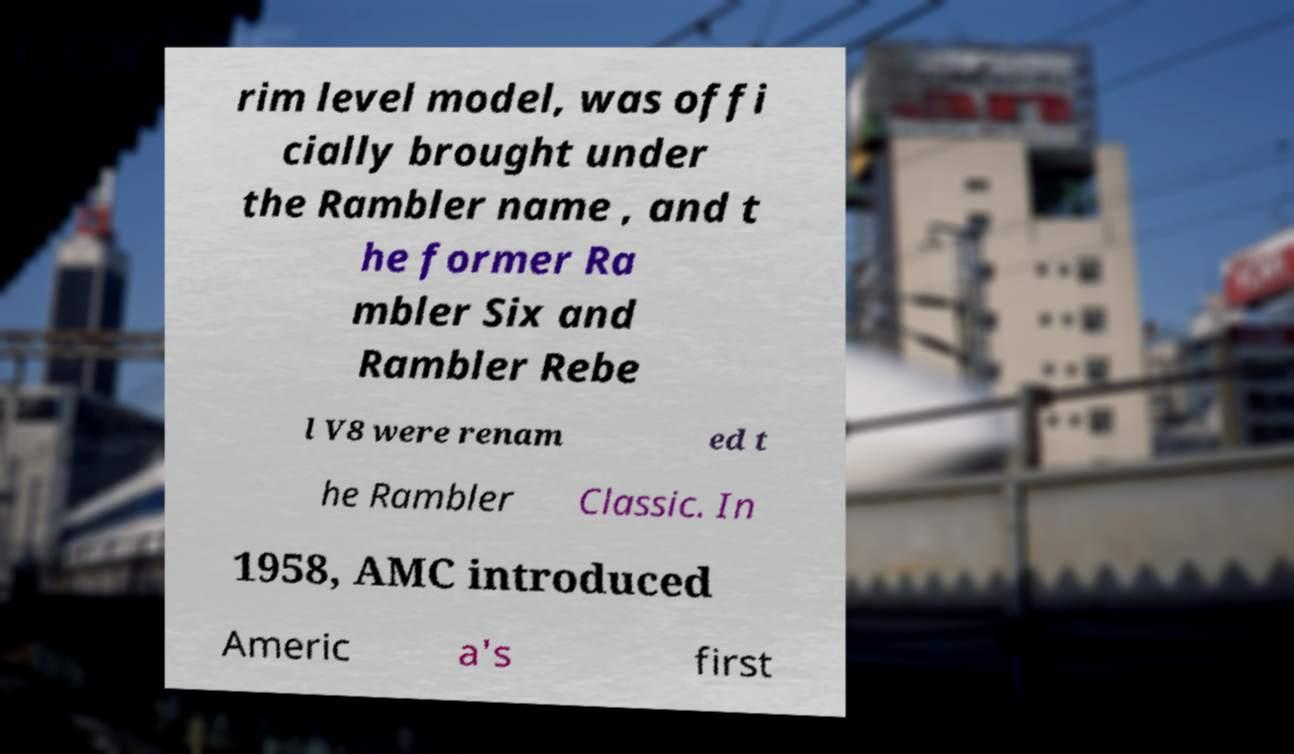Could you extract and type out the text from this image? rim level model, was offi cially brought under the Rambler name , and t he former Ra mbler Six and Rambler Rebe l V8 were renam ed t he Rambler Classic. In 1958, AMC introduced Americ a's first 